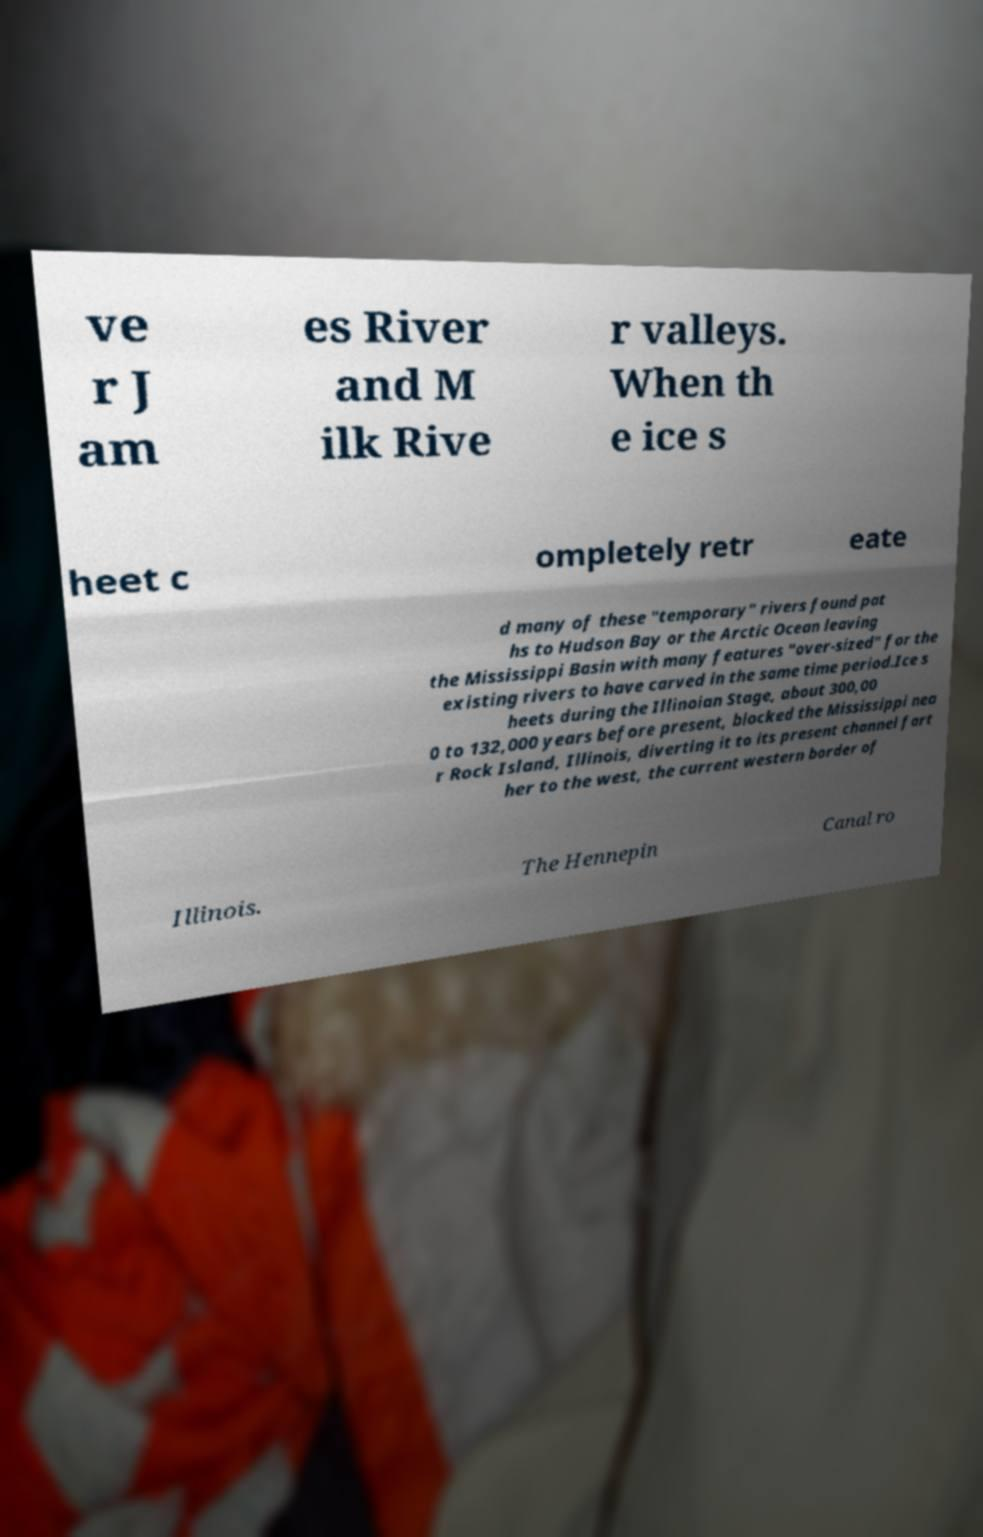For documentation purposes, I need the text within this image transcribed. Could you provide that? ve r J am es River and M ilk Rive r valleys. When th e ice s heet c ompletely retr eate d many of these "temporary" rivers found pat hs to Hudson Bay or the Arctic Ocean leaving the Mississippi Basin with many features "over-sized" for the existing rivers to have carved in the same time period.Ice s heets during the Illinoian Stage, about 300,00 0 to 132,000 years before present, blocked the Mississippi nea r Rock Island, Illinois, diverting it to its present channel fart her to the west, the current western border of Illinois. The Hennepin Canal ro 